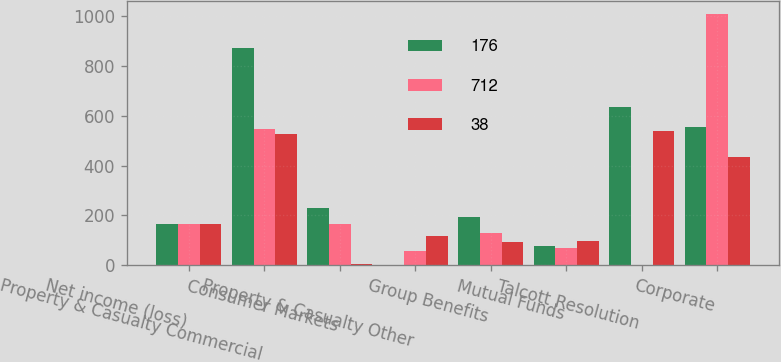Convert chart. <chart><loc_0><loc_0><loc_500><loc_500><stacked_bar_chart><ecel><fcel>Net income (loss)<fcel>Property & Casualty Commercial<fcel>Consumer Markets<fcel>Property & Casualty Other<fcel>Group Benefits<fcel>Mutual Funds<fcel>Talcott Resolution<fcel>Corporate<nl><fcel>176<fcel>166<fcel>870<fcel>229<fcel>2<fcel>192<fcel>76<fcel>634<fcel>555<nl><fcel>712<fcel>166<fcel>547<fcel>166<fcel>57<fcel>129<fcel>71<fcel>1<fcel>1009<nl><fcel>38<fcel>166<fcel>526<fcel>7<fcel>117<fcel>92<fcel>98<fcel>540<fcel>434<nl></chart> 